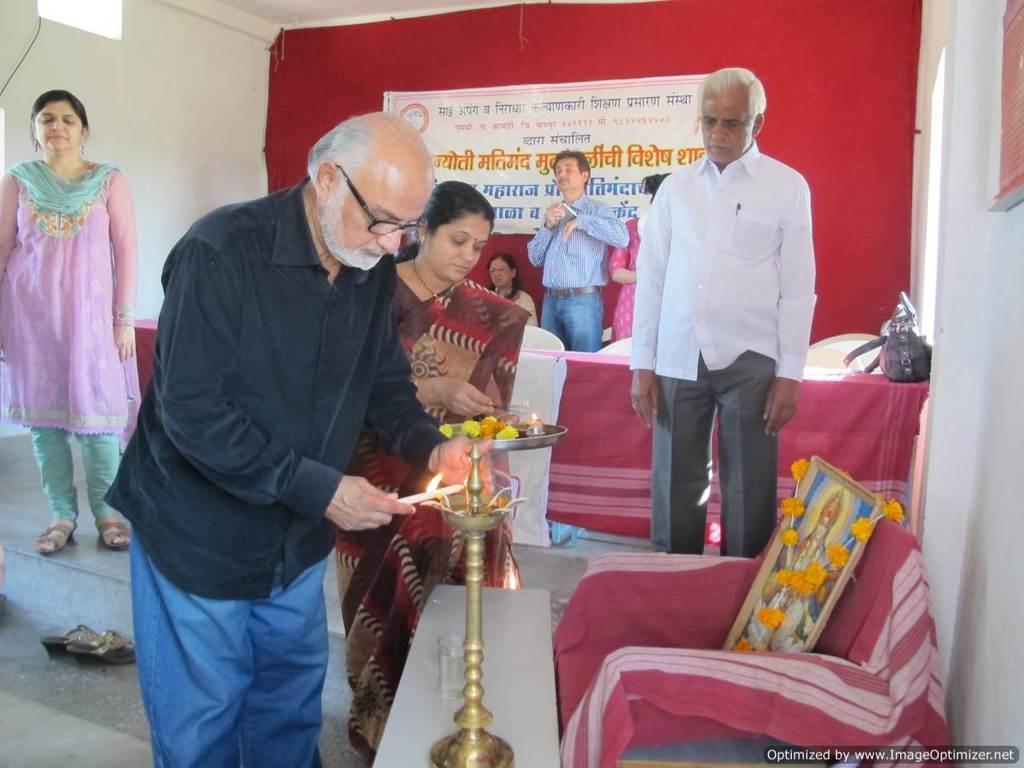How would you summarize this image in a sentence or two? In this image, I can see few people standing and a person sitting. This man is lighting a lamp. I can see a frame, which is placed in a chair. This is a table, which is covered with a cloth. I can see a handbag placed on the table. This is a banner. I can see a pair of sandals on the floor. At the bottom of the image, I can see the watermark. 